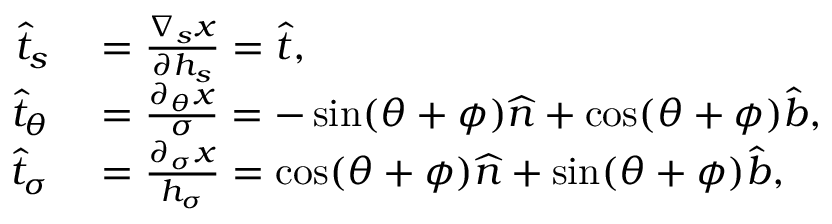<formula> <loc_0><loc_0><loc_500><loc_500>\begin{array} { r l } { \widehat { t } _ { s } } & = \frac { \nabla _ { s } x } { \partial h _ { s } } = \widehat { t } , } \\ { \widehat { t } _ { \theta } } & = \frac { \partial _ { \theta } x } { \sigma } = - \sin ( \theta + \phi ) \widehat { n } + \cos ( \theta + \phi ) \widehat { b } , } \\ { \widehat { t } _ { \sigma } } & = \frac { \partial _ { \sigma } x } { h _ { \sigma } } = \cos ( \theta + \phi ) \widehat { n } + \sin ( \theta + \phi ) \widehat { b } , } \end{array}</formula> 